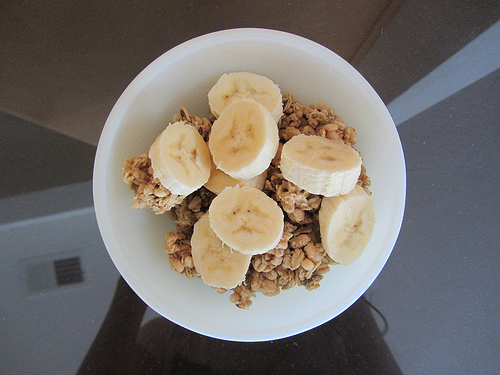<image>
Is the banana on the bowl? Yes. Looking at the image, I can see the banana is positioned on top of the bowl, with the bowl providing support. Is there a banana on the plate? Yes. Looking at the image, I can see the banana is positioned on top of the plate, with the plate providing support. 